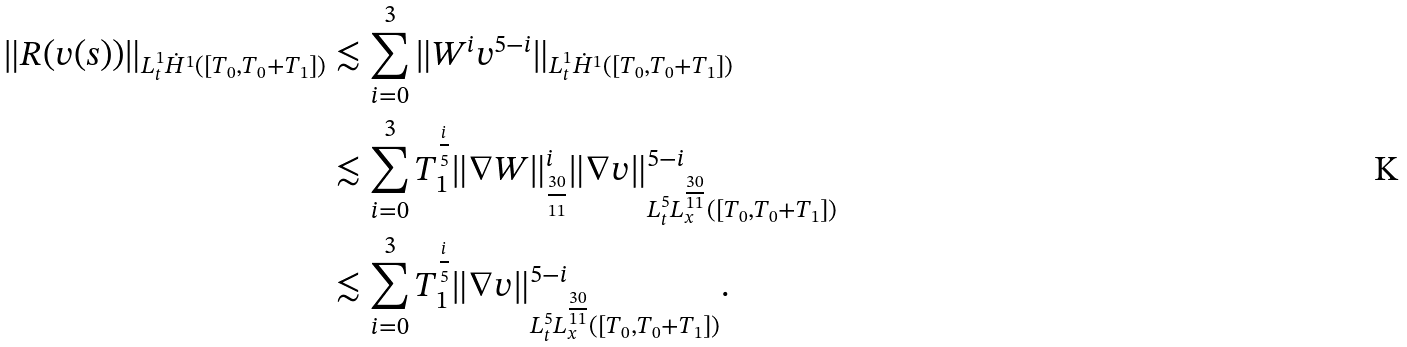<formula> <loc_0><loc_0><loc_500><loc_500>\| R ( v ( s ) ) \| _ { L _ { t } ^ { 1 } \dot { H } ^ { 1 } ( [ T _ { 0 } , T _ { 0 } + T _ { 1 } ] ) } & \lesssim \sum _ { i = 0 } ^ { 3 } \| W ^ { i } v ^ { 5 - i } \| _ { L _ { t } ^ { 1 } \dot { H } ^ { 1 } ( [ T _ { 0 } , T _ { 0 } + T _ { 1 } ] ) } \\ & \lesssim \sum _ { i = 0 } ^ { 3 } T _ { 1 } ^ { \frac { i } { 5 } } \| \nabla W \| _ { { \frac { 3 0 } { 1 1 } } } ^ { i } \| \nabla v \| _ { L _ { t } ^ { 5 } L _ { x } ^ { \frac { 3 0 } { 1 1 } } ( [ T _ { 0 } , T _ { 0 } + T _ { 1 } ] ) } ^ { 5 - i } \\ & \lesssim \sum _ { i = 0 } ^ { 3 } T _ { 1 } ^ { \frac { i } { 5 } } \| \nabla v \| _ { L _ { t } ^ { 5 } L _ { x } ^ { \frac { 3 0 } { 1 1 } } ( [ T _ { 0 } , T _ { 0 } + T _ { 1 } ] ) } ^ { 5 - i } .</formula> 